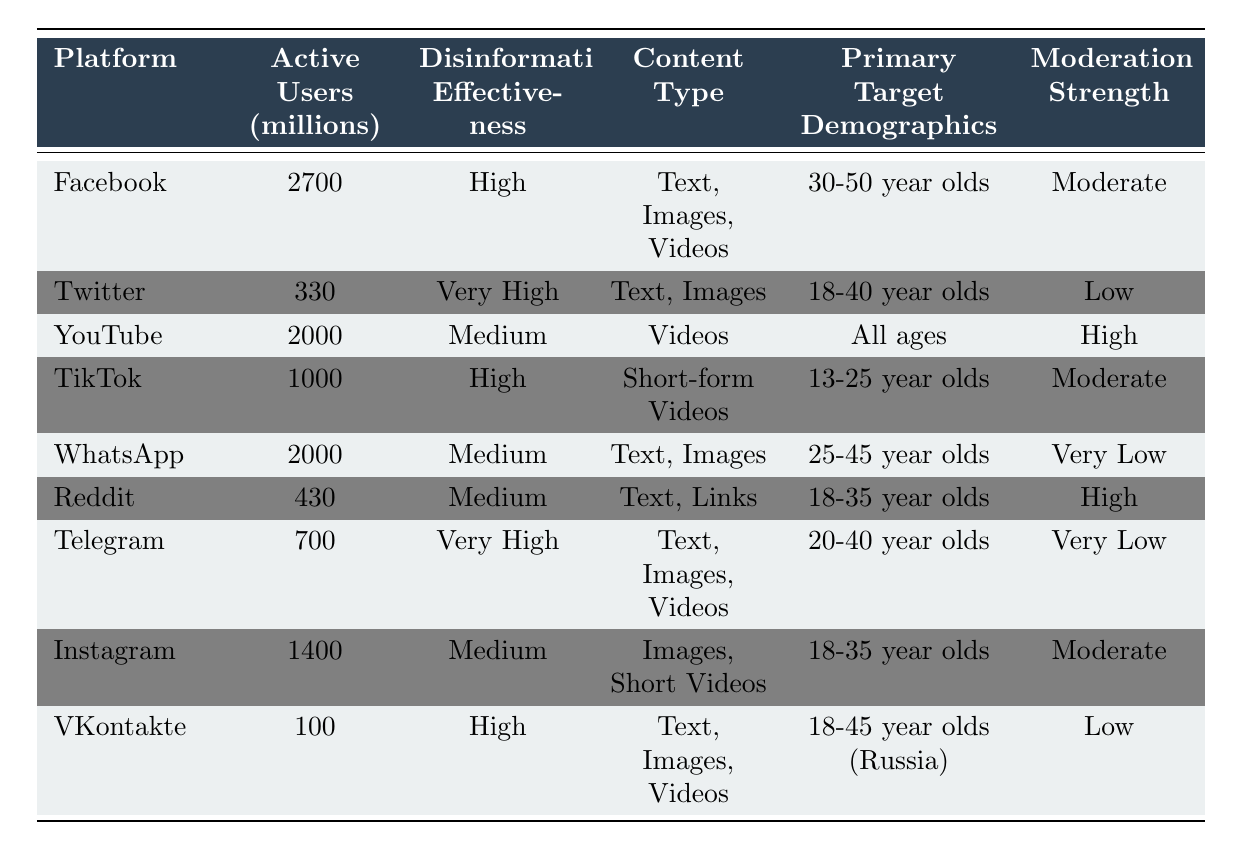What is the active user count for Twitter? From the table, the active user count for Twitter is listed under the "Active Users (millions)" column next to "Twitter." The figure is 330 million users.
Answer: 330 Which platform has the highest disinformation effectiveness rating? By looking at the "Disinformation Effectiveness" column, Twitter and Telegram both have the rating "Very High," indicating that these two platforms have the highest effectiveness for disinformation campaigns.
Answer: Twitter and Telegram What is the primary content type used on TikTok? The table shows that TikTok's primary content type is listed as "Short-form Videos." This can be found directly in the "Content Type" column for TikTok.
Answer: Short-form Videos How many active users are there on WhatsApp and how does it compare to Facebook? WhatsApp has 2000 million active users, while Facebook has 2700 million. The difference between Facebook and WhatsApp is 2700 - 2000 = 700 million users, showing that Facebook has more active users than WhatsApp.
Answer: WhatsApp: 2000 million, Facebook: 2700 million, Difference: 700 million Is the moderation strength for Instagram high? The moderation strength for Instagram, as per the table, is listed as "Moderate." Therefore, the claim that moderation strength is high is false.
Answer: No Which platform has the highest number of active users and what is the disinformation effectiveness rating for that platform? The platform with the highest active users is Facebook with 2700 million. Looking in the "Disinformation Effectiveness" column, Facebook's rating is "High." Thus, Facebook has the highest number of users and is rated as having high effectiveness.
Answer: Facebook, High What is the average number of active users across all listed platforms? To find the average, sum all active users: 2700 + 330 + 2000 + 1000 + 2000 + 430 + 700 + 1400 + 100 = 10360 million. There are 9 platforms, so the average is 10360 / 9 ≈ 1151.11 million. Round off gives approximately 1151 million.
Answer: Approximately 1151 million Which demographic is primarily targeted by Reddit users? The table indicates that the primary target demographic for Reddit is "18-35 year olds." This information is directly found in the "Primary Target Demographics" column.
Answer: 18-35 year olds 